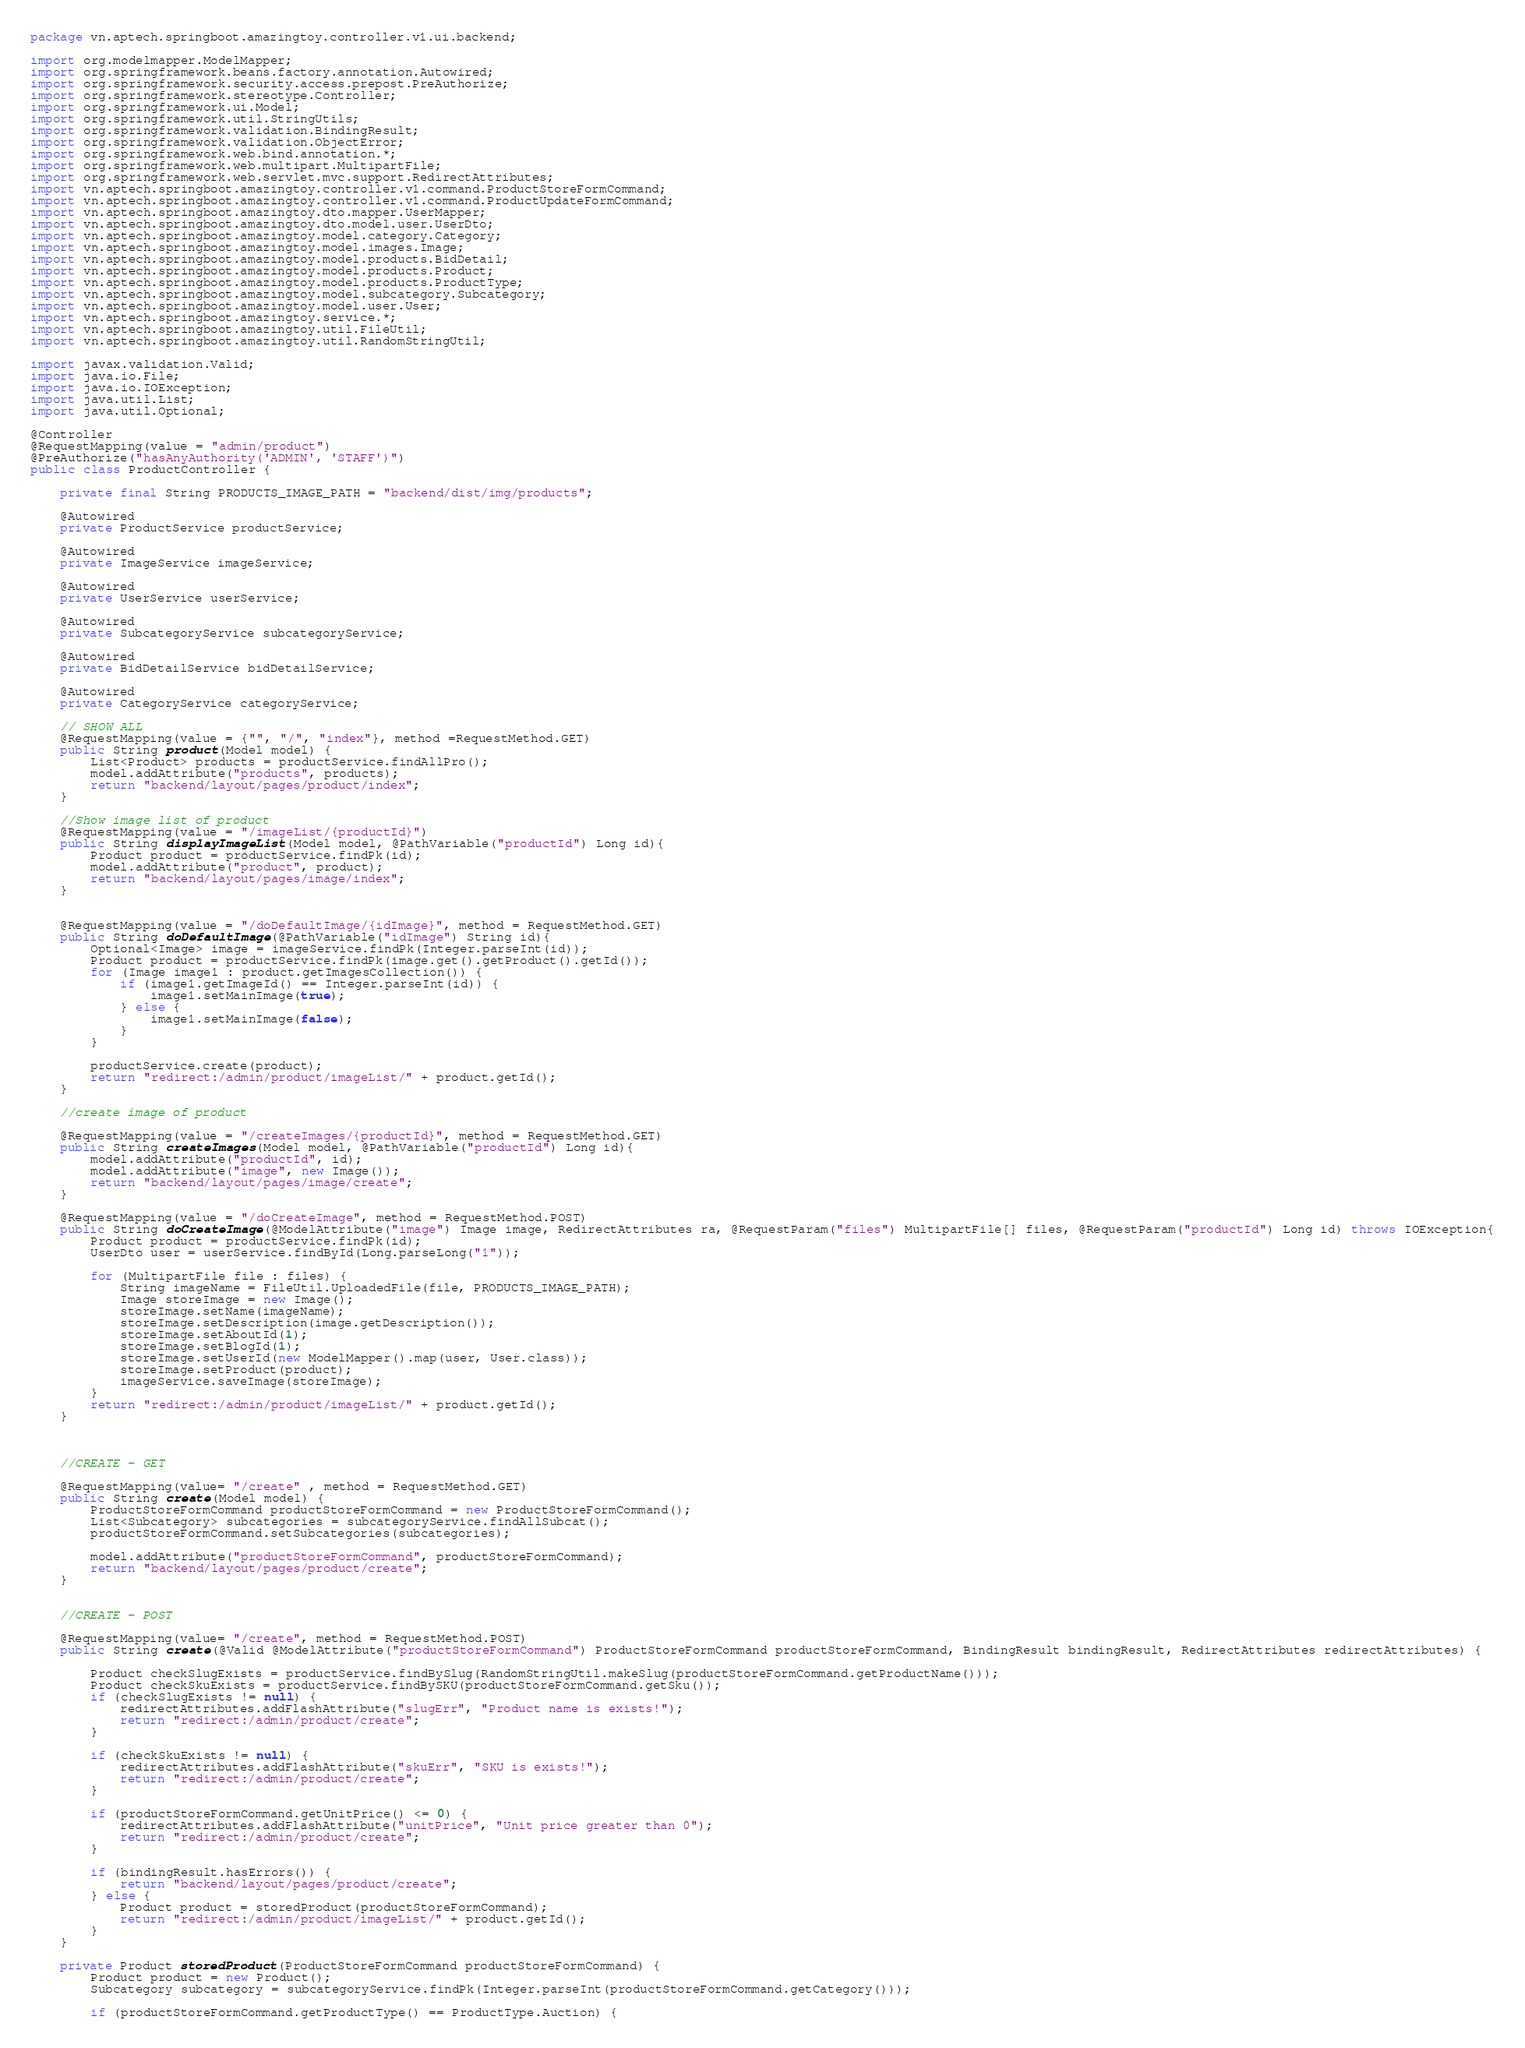<code> <loc_0><loc_0><loc_500><loc_500><_Java_>package vn.aptech.springboot.amazingtoy.controller.v1.ui.backend;

import org.modelmapper.ModelMapper;
import org.springframework.beans.factory.annotation.Autowired;
import org.springframework.security.access.prepost.PreAuthorize;
import org.springframework.stereotype.Controller;
import org.springframework.ui.Model;
import org.springframework.util.StringUtils;
import org.springframework.validation.BindingResult;
import org.springframework.validation.ObjectError;
import org.springframework.web.bind.annotation.*;
import org.springframework.web.multipart.MultipartFile;
import org.springframework.web.servlet.mvc.support.RedirectAttributes;
import vn.aptech.springboot.amazingtoy.controller.v1.command.ProductStoreFormCommand;
import vn.aptech.springboot.amazingtoy.controller.v1.command.ProductUpdateFormCommand;
import vn.aptech.springboot.amazingtoy.dto.mapper.UserMapper;
import vn.aptech.springboot.amazingtoy.dto.model.user.UserDto;
import vn.aptech.springboot.amazingtoy.model.category.Category;
import vn.aptech.springboot.amazingtoy.model.images.Image;
import vn.aptech.springboot.amazingtoy.model.products.BidDetail;
import vn.aptech.springboot.amazingtoy.model.products.Product;
import vn.aptech.springboot.amazingtoy.model.products.ProductType;
import vn.aptech.springboot.amazingtoy.model.subcategory.Subcategory;
import vn.aptech.springboot.amazingtoy.model.user.User;
import vn.aptech.springboot.amazingtoy.service.*;
import vn.aptech.springboot.amazingtoy.util.FileUtil;
import vn.aptech.springboot.amazingtoy.util.RandomStringUtil;

import javax.validation.Valid;
import java.io.File;
import java.io.IOException;
import java.util.List;
import java.util.Optional;

@Controller
@RequestMapping(value = "admin/product")
@PreAuthorize("hasAnyAuthority('ADMIN', 'STAFF')")
public class ProductController {

    private final String PRODUCTS_IMAGE_PATH = "backend/dist/img/products";

    @Autowired
    private ProductService productService;

    @Autowired
    private ImageService imageService;

    @Autowired
    private UserService userService;

    @Autowired
    private SubcategoryService subcategoryService;

    @Autowired
    private BidDetailService bidDetailService;

    @Autowired
    private CategoryService categoryService;

    // SHOW ALL
    @RequestMapping(value = {"", "/", "index"}, method =RequestMethod.GET)
    public String product(Model model) {
        List<Product> products = productService.findAllPro();
        model.addAttribute("products", products);
        return "backend/layout/pages/product/index";
    }

    //Show image list of product
    @RequestMapping(value = "/imageList/{productId}")
    public String displayImageList(Model model, @PathVariable("productId") Long id){
        Product product = productService.findPk(id);
        model.addAttribute("product", product);
        return "backend/layout/pages/image/index";
    }


    @RequestMapping(value = "/doDefaultImage/{idImage}", method = RequestMethod.GET)
    public String doDefaultImage(@PathVariable("idImage") String id){
        Optional<Image> image = imageService.findPk(Integer.parseInt(id));
        Product product = productService.findPk(image.get().getProduct().getId());
        for (Image image1 : product.getImagesCollection()) {
            if (image1.getImageId() == Integer.parseInt(id)) {
                image1.setMainImage(true);
            } else {
                image1.setMainImage(false);
            }
        }

        productService.create(product);
        return "redirect:/admin/product/imageList/" + product.getId();
    }

    //create image of product

    @RequestMapping(value = "/createImages/{productId}", method = RequestMethod.GET)
    public String createImages(Model model, @PathVariable("productId") Long id){
        model.addAttribute("productId", id);
        model.addAttribute("image", new Image());
        return "backend/layout/pages/image/create";
    }

    @RequestMapping(value = "/doCreateImage", method = RequestMethod.POST)
    public String doCreateImage(@ModelAttribute("image") Image image, RedirectAttributes ra, @RequestParam("files") MultipartFile[] files, @RequestParam("productId") Long id) throws IOException{
        Product product = productService.findPk(id);
        UserDto user = userService.findById(Long.parseLong("1"));

        for (MultipartFile file : files) {
            String imageName = FileUtil.UploadedFile(file, PRODUCTS_IMAGE_PATH);
            Image storeImage = new Image();
            storeImage.setName(imageName);
            storeImage.setDescription(image.getDescription());
            storeImage.setAboutId(1);
            storeImage.setBlogId(1);
            storeImage.setUserId(new ModelMapper().map(user, User.class));
            storeImage.setProduct(product);
            imageService.saveImage(storeImage);
        }
        return "redirect:/admin/product/imageList/" + product.getId();
    }



    //CREATE - GET

    @RequestMapping(value= "/create" , method = RequestMethod.GET)
    public String create(Model model) {
        ProductStoreFormCommand productStoreFormCommand = new ProductStoreFormCommand();
        List<Subcategory> subcategories = subcategoryService.findAllSubcat();
        productStoreFormCommand.setSubcategories(subcategories);

        model.addAttribute("productStoreFormCommand", productStoreFormCommand);
        return "backend/layout/pages/product/create";
    }


    //CREATE - POST

    @RequestMapping(value= "/create", method = RequestMethod.POST)
    public String create(@Valid @ModelAttribute("productStoreFormCommand") ProductStoreFormCommand productStoreFormCommand, BindingResult bindingResult, RedirectAttributes redirectAttributes) {

        Product checkSlugExists = productService.findBySlug(RandomStringUtil.makeSlug(productStoreFormCommand.getProductName()));
        Product checkSkuExists = productService.findBySKU(productStoreFormCommand.getSku());
        if (checkSlugExists != null) {
            redirectAttributes.addFlashAttribute("slugErr", "Product name is exists!");
            return "redirect:/admin/product/create";
        }

        if (checkSkuExists != null) {
            redirectAttributes.addFlashAttribute("skuErr", "SKU is exists!");
            return "redirect:/admin/product/create";
        }

        if (productStoreFormCommand.getUnitPrice() <= 0) {
            redirectAttributes.addFlashAttribute("unitPrice", "Unit price greater than 0");
            return "redirect:/admin/product/create";
        }

        if (bindingResult.hasErrors()) {
            return "backend/layout/pages/product/create";
        } else {
            Product product = storedProduct(productStoreFormCommand);
            return "redirect:/admin/product/imageList/" + product.getId();
        }
    }

    private Product storedProduct(ProductStoreFormCommand productStoreFormCommand) {
        Product product = new Product();
        Subcategory subcategory = subcategoryService.findPk(Integer.parseInt(productStoreFormCommand.getCategory()));

        if (productStoreFormCommand.getProductType() == ProductType.Auction) {
</code> 